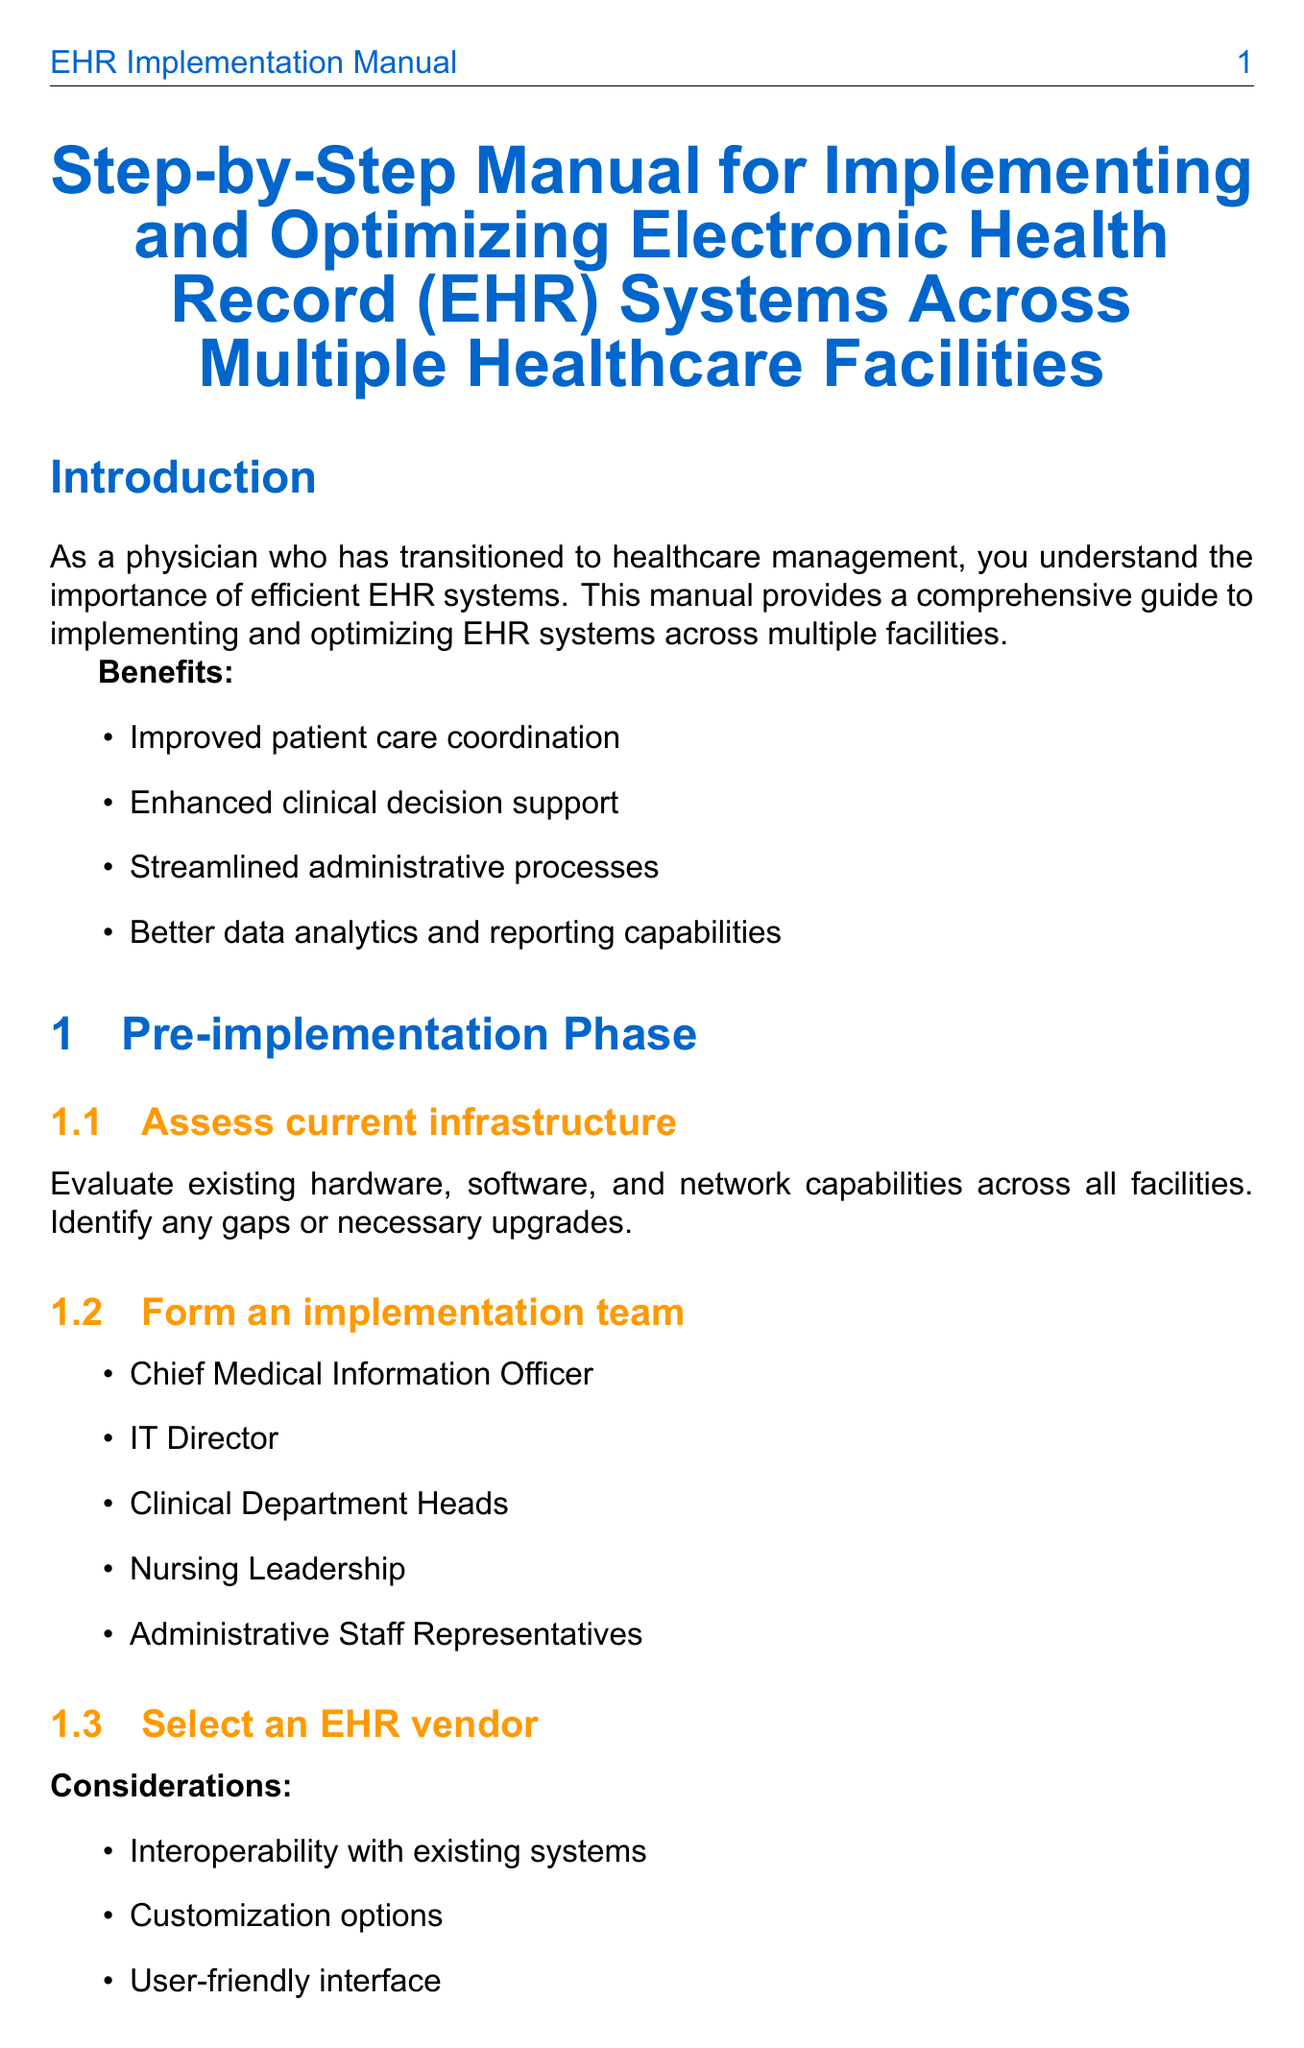What are the benefits of EHR systems? The benefits listed in the introduction include improved patient care coordination, enhanced clinical decision support, streamlined administrative processes, and better data analytics and reporting capabilities.
Answer: Improved patient care coordination, enhanced clinical decision support, streamlined administrative processes, better data analytics and reporting capabilities Who should be part of the implementation team? The document specifies key members of the implementation team, including the Chief Medical Information Officer, IT Director, Clinical Department Heads, Nursing Leadership, and Administrative Staff Representatives.
Answer: Chief Medical Information Officer, IT Director, Clinical Department Heads, Nursing Leadership, Administrative Staff Representatives What is the first step in the implementation phase? The first step listed in the implementation phase is data migration and system setup, which includes converting paper records to digital format and importing existing digital records.
Answer: Data migration and system setup What should the training for staff include? The document outlines several methods for staff training, such as role-based training sessions, online learning modules, and hands-on practice with test patient scenarios.
Answer: Role-based training sessions, online learning modules, hands-on practice with test patient scenarios What is a recommended vendor for EHR systems? The document lists several recommended vendors, including Epic Systems, Cerner, Allscripts, Meditech, and athenahealth.
Answer: Epic Systems, Cerner, Allscripts, Meditech, athenahealth What are key learnings from the Mayo Clinic case study? The case study of the Mayo Clinic emphasizes the importance of leadership alignment, benefits of a phased implementation approach, and value of extensive pre-implementation planning.
Answer: Importance of leadership alignment, benefits of a phased implementation approach, value of extensive pre-implementation planning What is one best practice for EHR implementation? The document provides several best practices, one of which is to engage clinical staff in the selection and customization process.
Answer: Engage clinical staff in the selection and customization process What is the ultimate goal of EHR implementation? The conclusion of the document states that the ultimate goal is to leverage technology to improve patient care and operational efficiency.
Answer: Leverage technology to improve patient care and operational efficiency 